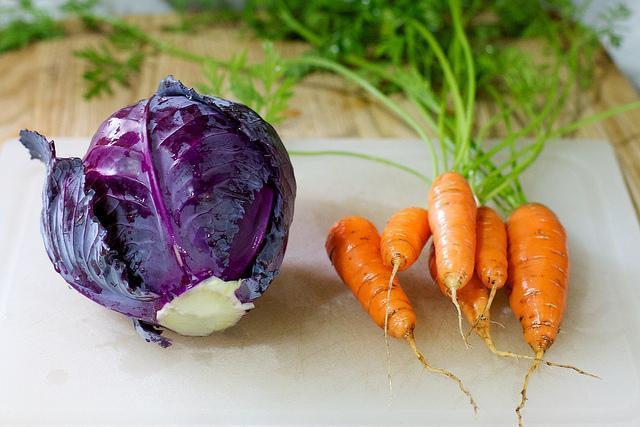How many carrots are visible?
Give a very brief answer. 5. How many cars are in the road?
Give a very brief answer. 0. 